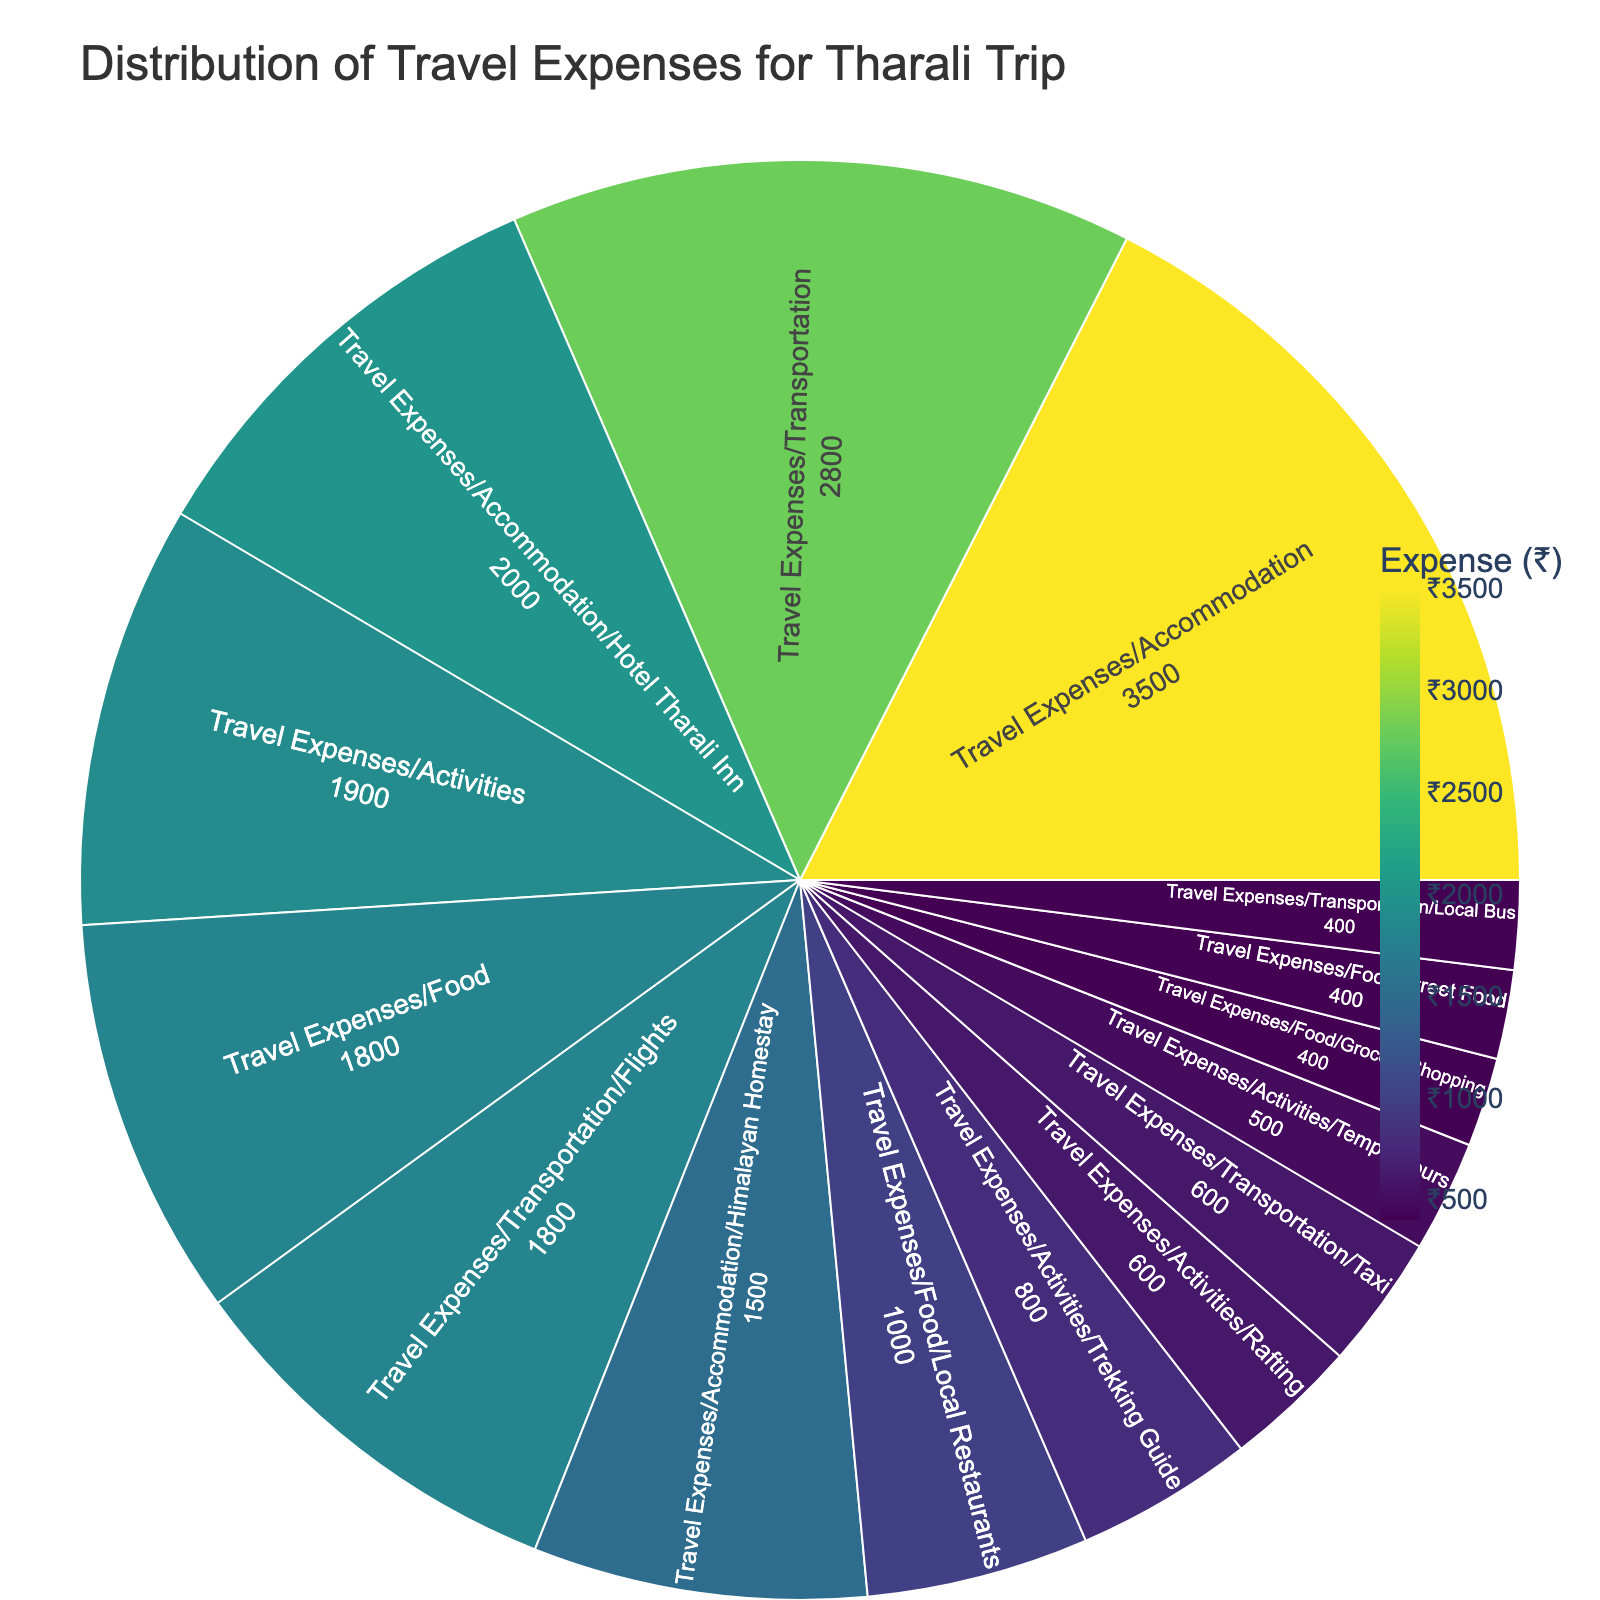What's the title of the figure? The title is displayed at the top of the figure, indicating the main subject or purpose of the plot. It provides context to the viewer about what the visualization represents.
Answer: Distribution of Travel Expenses for Tharali Trip What is the largest expense category? By examining the size of the segments in the Sunburst plot, the largest segment corresponds to the largest expense category.
Answer: Accommodation What is the combined expense for food and activities? Adding the expenses for the 'Food' and 'Activities' categories as listed in the plot. ₹1800 + ₹1900 = ₹3700.
Answer: ₹3700 Which subcategory under accommodation has the higher expense? Comparing the expenses of the 'Hotel Tharali Inn' and 'Himalayan Homestay' subcategories under Accommodation.
Answer: Hotel Tharali Inn How much was spent on local transportation in total (bus + taxi)? Adding the expenses from the 'Local Bus' and 'Taxi' subcategories. ₹400 + ₹600 = ₹1000.
Answer: ₹1000 What's the least expensive subcategory under food? Comparing the expenses of all subcategories under 'Food', the one with the lowest value is the least expensive.
Answer: Street Food / Grocery Shopping How much more was spent on flights than on rafting? Subtract the expense of 'Rafting' from the expense of 'Flights'. ₹1800 - ₹600 = ₹1200.
Answer: ₹1200 Which activity had the highest expense? Within the 'Activities' category, observe which subcategory has the highest expense.
Answer: Trekking Guide What's the total expense on transportation? Summing up all the transportation-related expenses: flights, local bus, and taxi. ₹1800 + ₹400 + ₹600 = ₹2800.
Answer: ₹2800 Which category has the smallest total expense? Among the main categories (Accommodation, Transportation, Food, Activities), identifying the one with the smallest expense by comparing the segments.
Answer: Food 